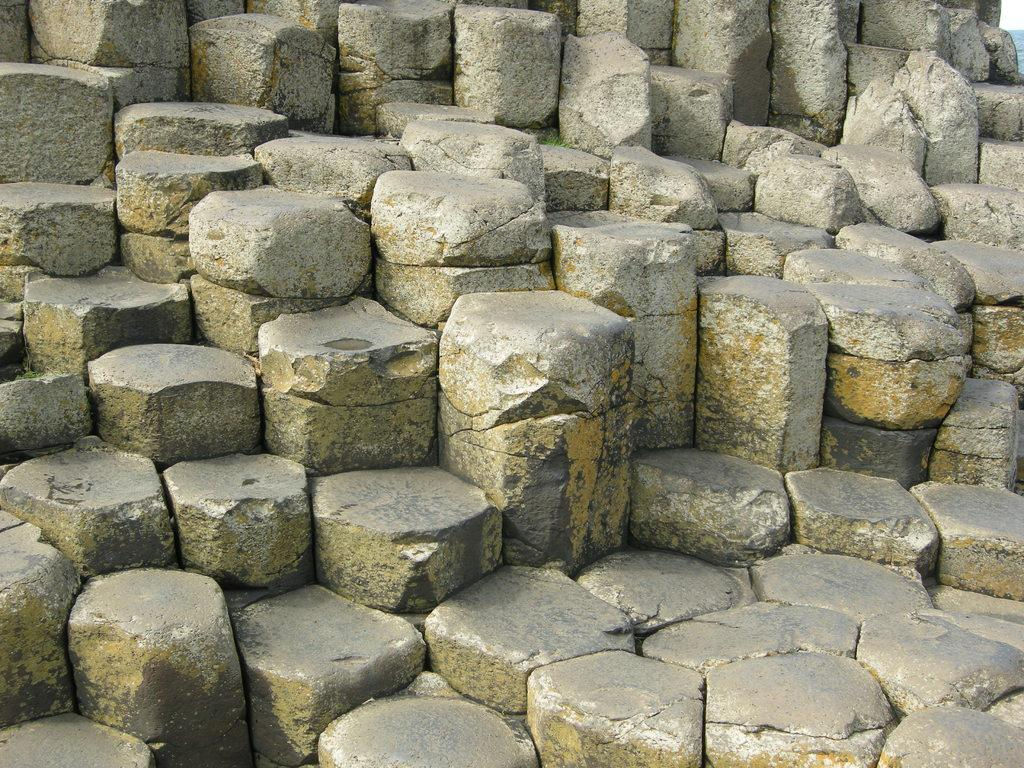What type of material are the blocks made of in the image? The blocks in the image are made of concrete. Can you describe the appearance of the blocks in the image? The blocks are many in number and are made of concrete. How many pages are in the notebook that is visible in the image? There is no notebook present in the image; it only features many concrete blocks. 